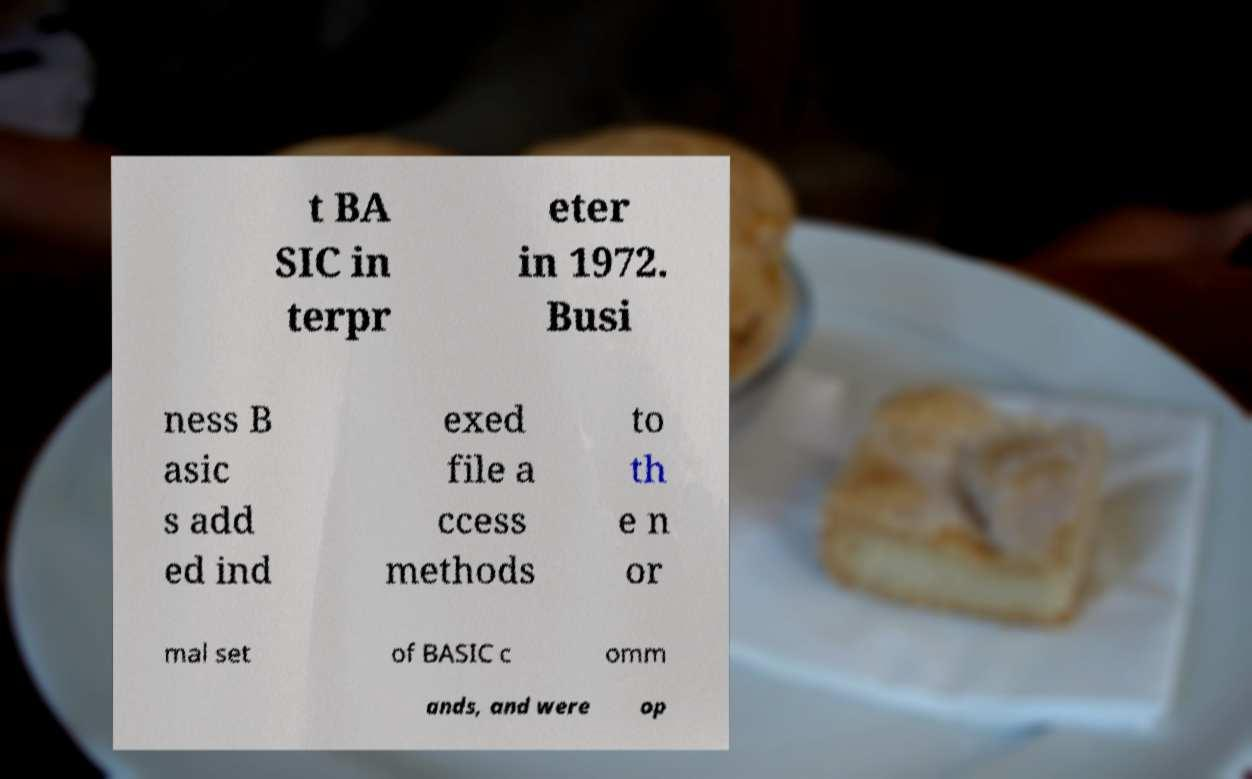I need the written content from this picture converted into text. Can you do that? t BA SIC in terpr eter in 1972. Busi ness B asic s add ed ind exed file a ccess methods to th e n or mal set of BASIC c omm ands, and were op 